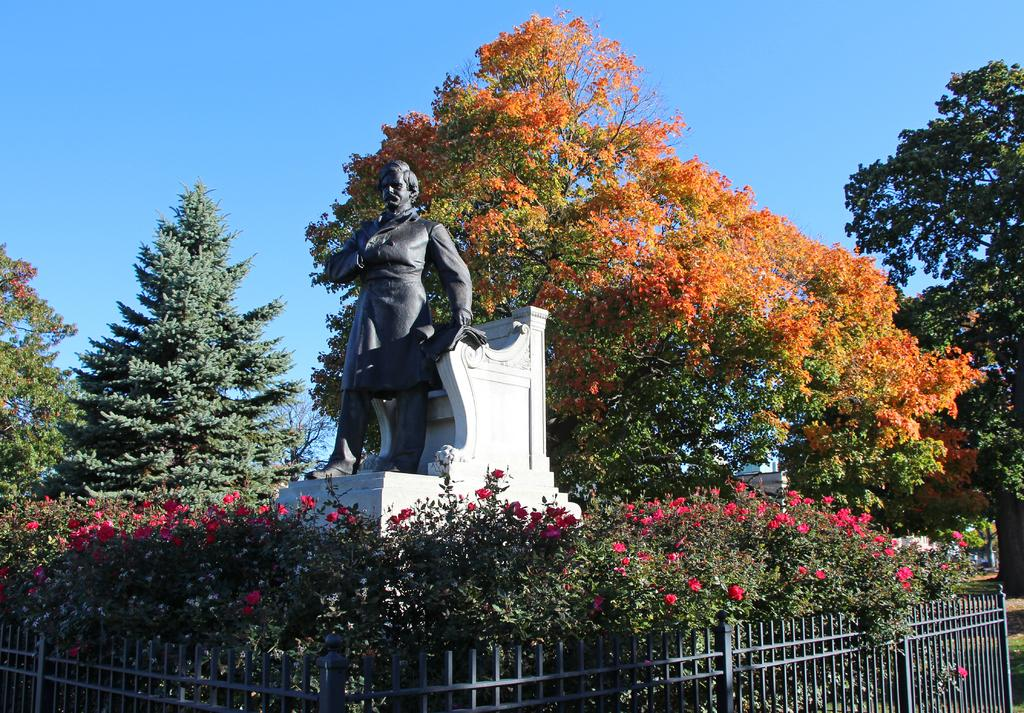What type of structure can be seen in the image? There is a fence in the image. What kind of vegetation is present in the image? There are plants with flowers and trees in the image. Can you describe any other objects or features in the image? There is a statue in the image. What is the color of the sky in the background? The sky in the background is blue. How many kittens are playing around the statue in the image? There are no kittens present in the image. What type of dinosaur can be seen walking near the fence in the image? There are no dinosaurs present in the image. 